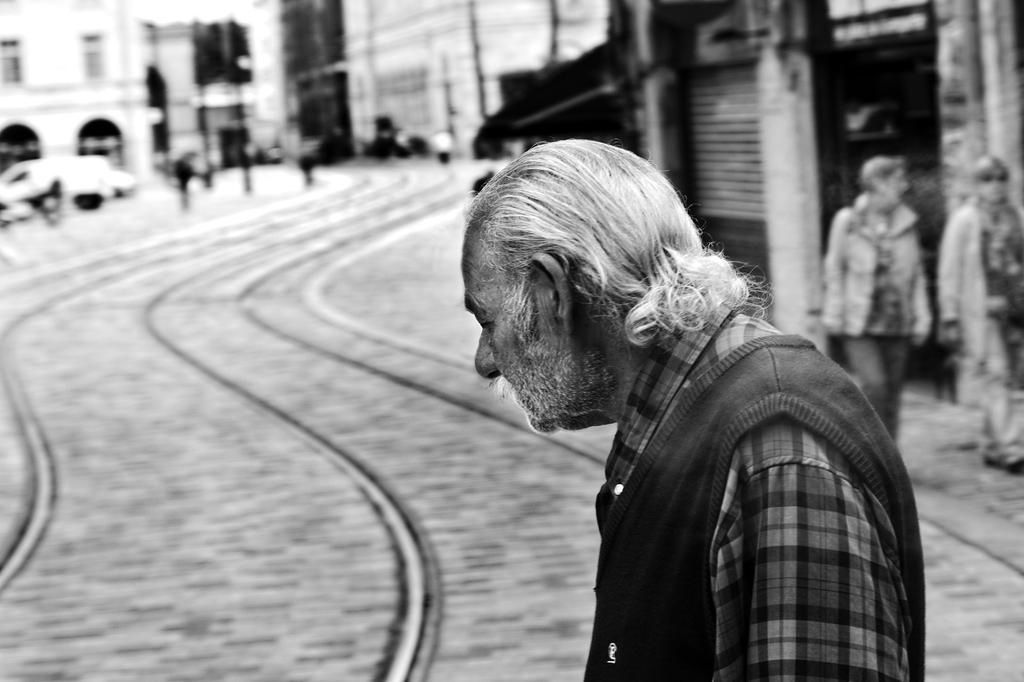Could you give a brief overview of what you see in this image? In this picture there is a old man standing and there are few tracks beside him and there are two persons standing in the right corner and there are few buildings,vehicles and some other objects in the background. 